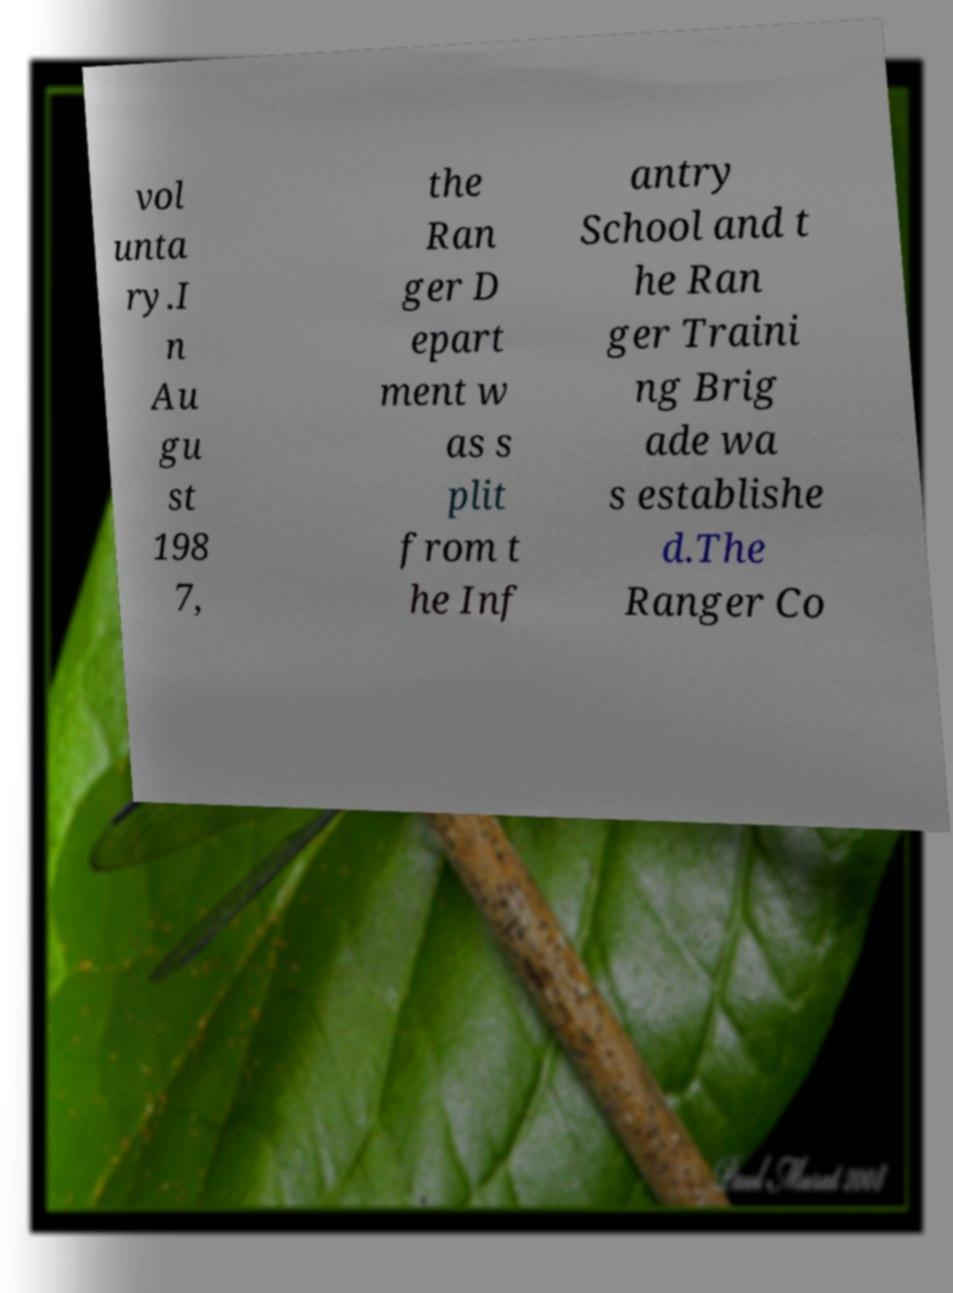Could you assist in decoding the text presented in this image and type it out clearly? vol unta ry.I n Au gu st 198 7, the Ran ger D epart ment w as s plit from t he Inf antry School and t he Ran ger Traini ng Brig ade wa s establishe d.The Ranger Co 